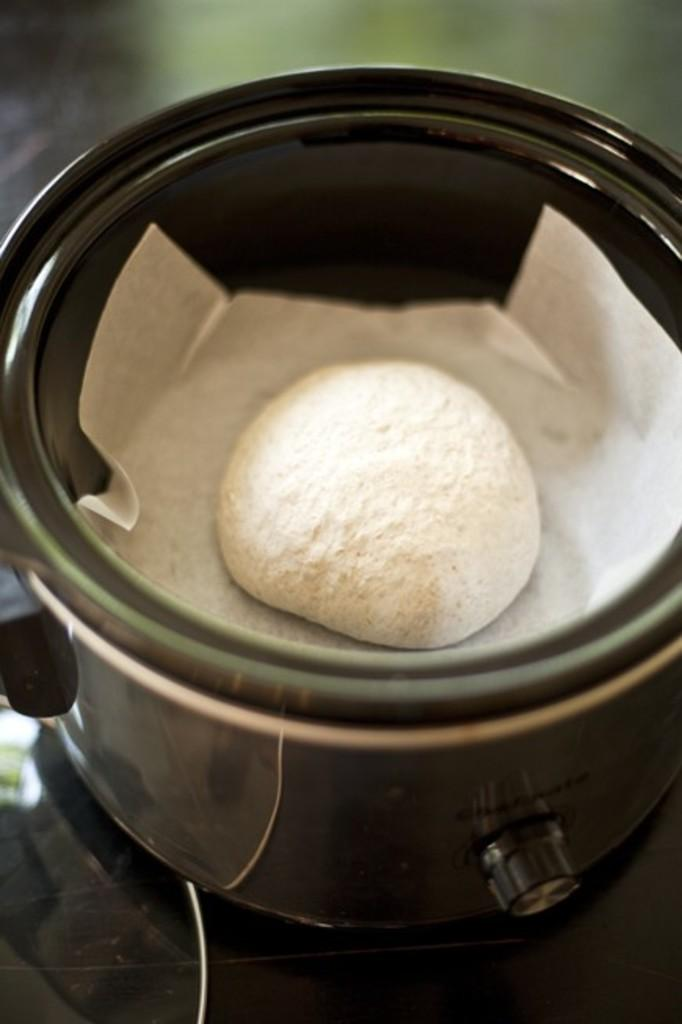What is the main object in the image? There is a bowl in the image. What is the bowl placed on? The bowl is on an object. What is inside the bowl? There is a paper and a food item in the bowl. How many times does the square kick the unit in the image? There is no square or unit present in the image, and therefore no such activity can be observed. 